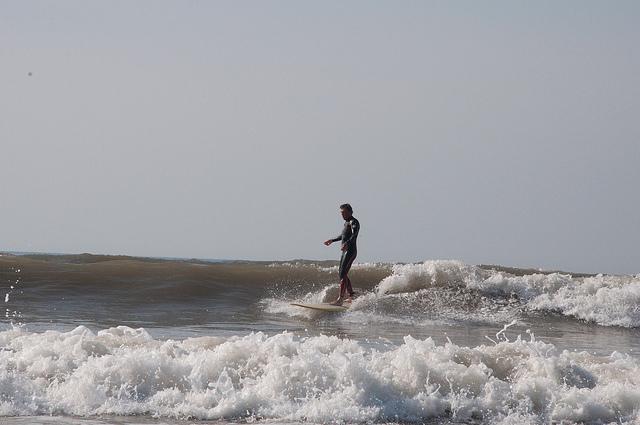Is this man riding a wave in the ocean?
Quick response, please. Yes. Is he wearing a wetsuit?
Quick response, please. Yes. What is the man doing?
Quick response, please. Surfing. Is this a photo of a forest?
Short answer required. No. How many birds are in the photo?
Quick response, please. 0. Is this near or far from the shore?
Write a very short answer. Near. Is this person a good surfer?
Be succinct. Yes. 